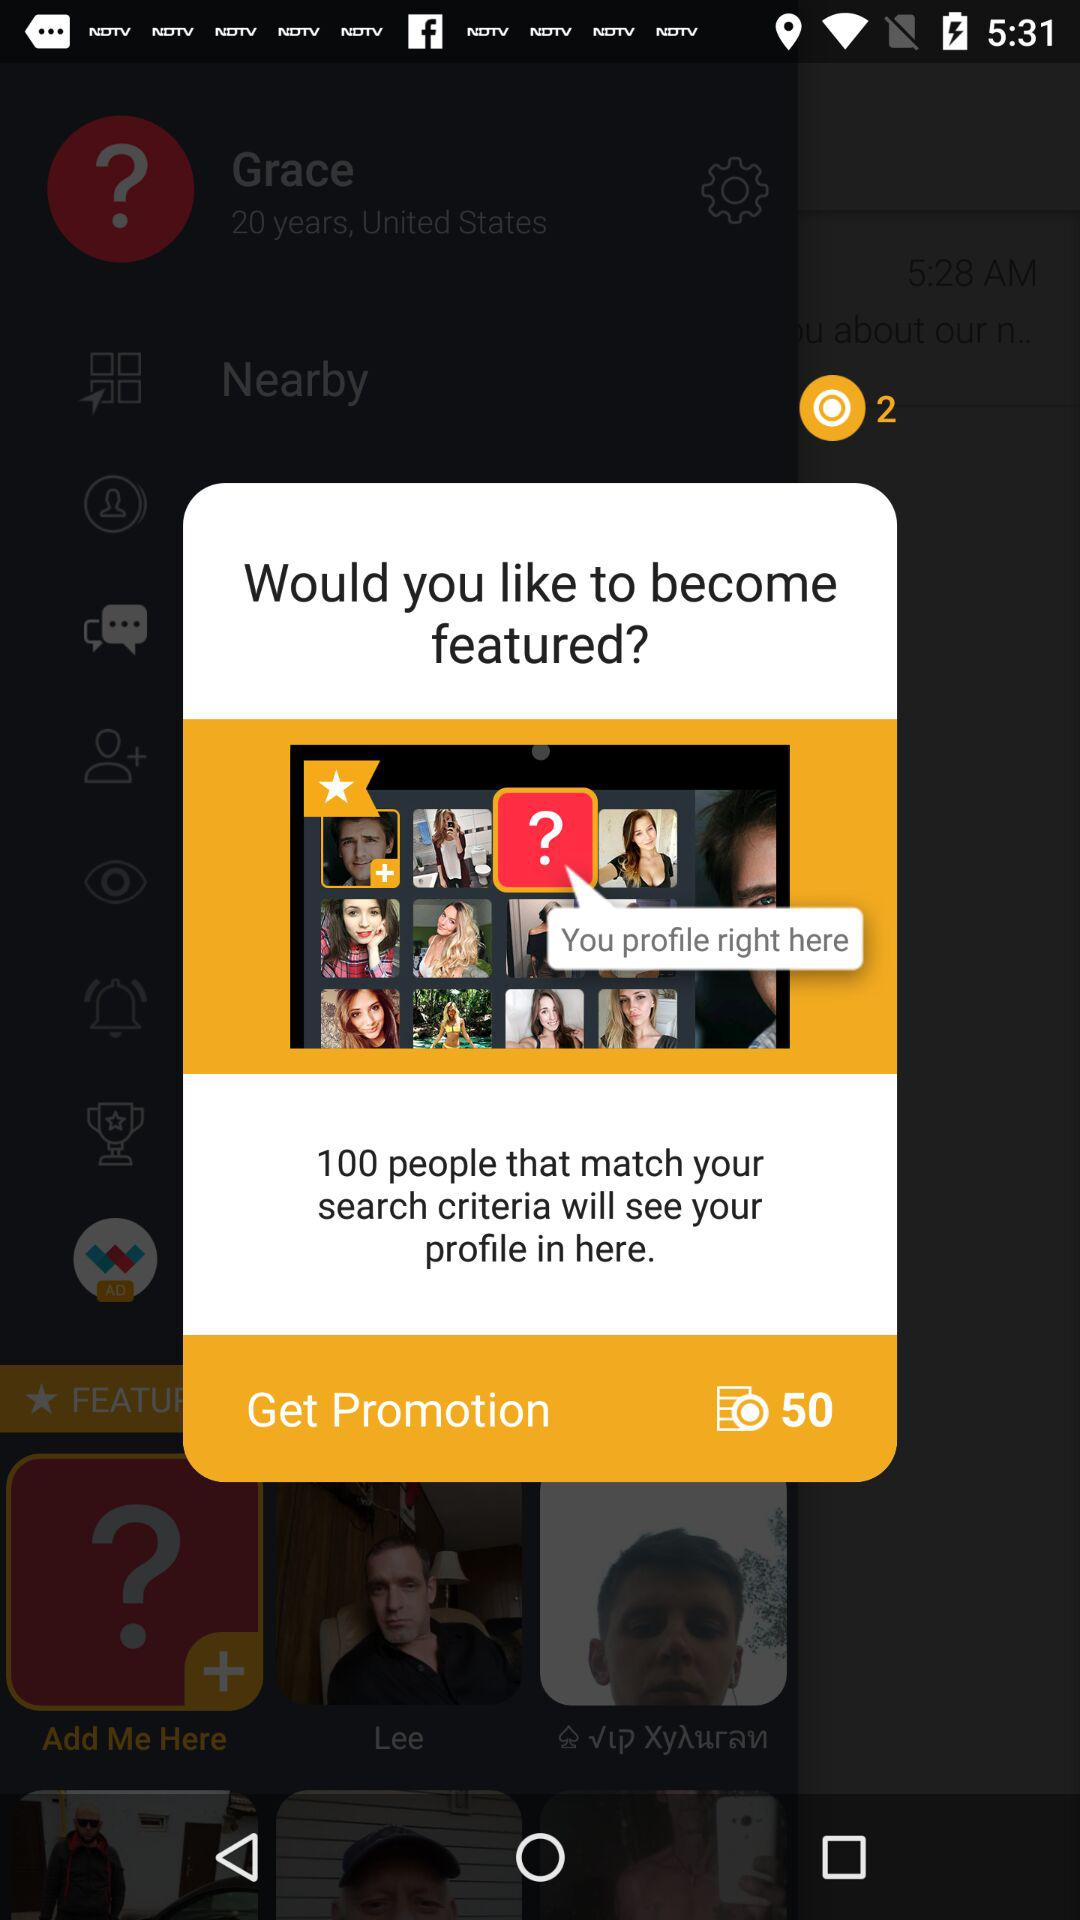Can you explain what the 'Get Promotion' button does and at what cost? Clicking the 'Get Promotion' button likely initiates a process to feature your profile, potentially in the highlighted section shown. The image indicates a cost of 50 units of currency, though the exact currency is not specified. 